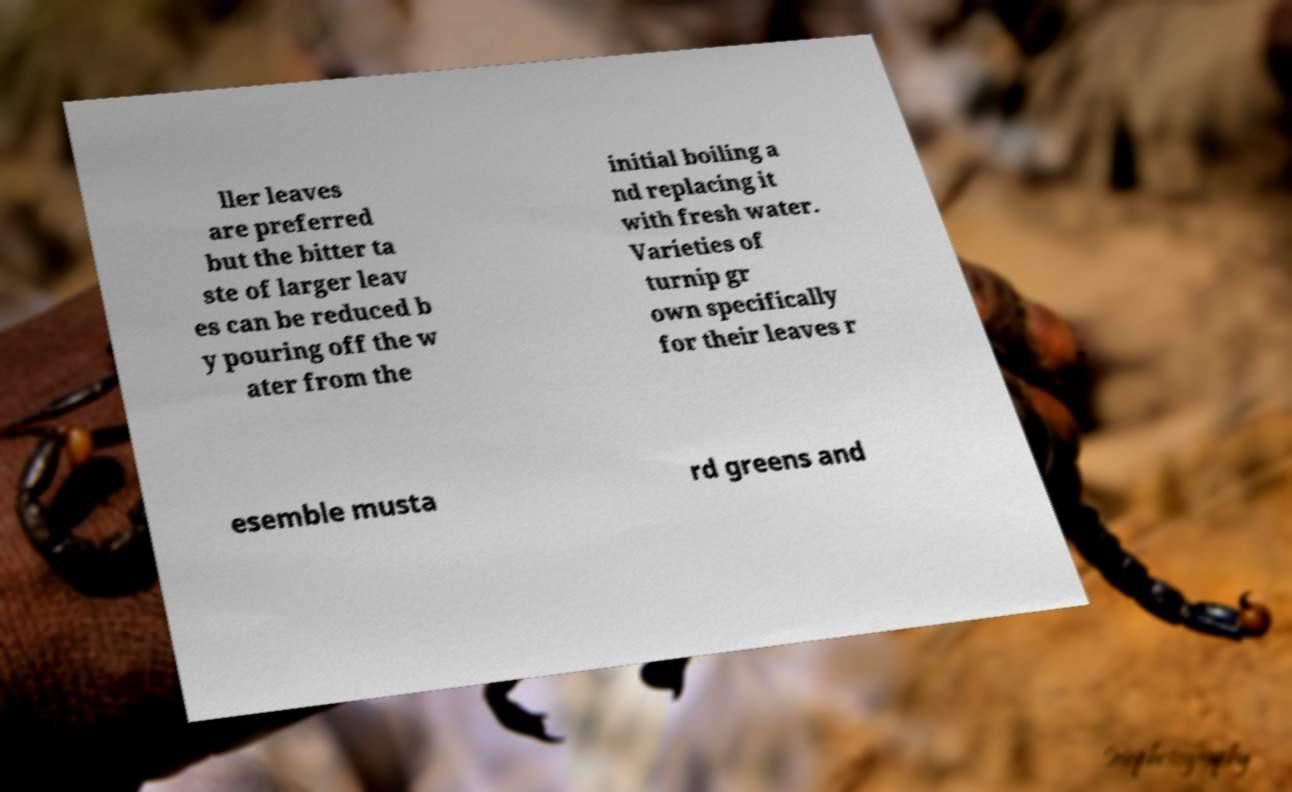What messages or text are displayed in this image? I need them in a readable, typed format. ller leaves are preferred but the bitter ta ste of larger leav es can be reduced b y pouring off the w ater from the initial boiling a nd replacing it with fresh water. Varieties of turnip gr own specifically for their leaves r esemble musta rd greens and 